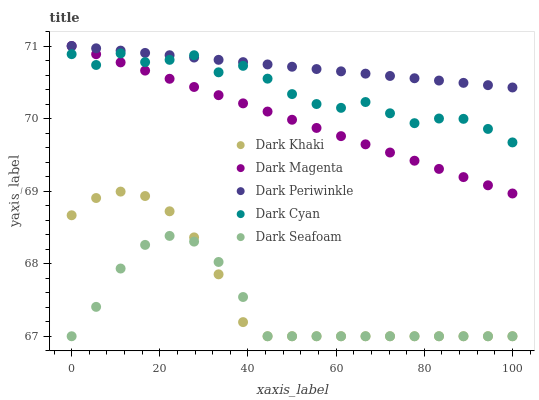Does Dark Seafoam have the minimum area under the curve?
Answer yes or no. Yes. Does Dark Periwinkle have the maximum area under the curve?
Answer yes or no. Yes. Does Dark Cyan have the minimum area under the curve?
Answer yes or no. No. Does Dark Cyan have the maximum area under the curve?
Answer yes or no. No. Is Dark Magenta the smoothest?
Answer yes or no. Yes. Is Dark Cyan the roughest?
Answer yes or no. Yes. Is Dark Seafoam the smoothest?
Answer yes or no. No. Is Dark Seafoam the roughest?
Answer yes or no. No. Does Dark Khaki have the lowest value?
Answer yes or no. Yes. Does Dark Cyan have the lowest value?
Answer yes or no. No. Does Dark Periwinkle have the highest value?
Answer yes or no. Yes. Does Dark Cyan have the highest value?
Answer yes or no. No. Is Dark Seafoam less than Dark Cyan?
Answer yes or no. Yes. Is Dark Magenta greater than Dark Seafoam?
Answer yes or no. Yes. Does Dark Cyan intersect Dark Magenta?
Answer yes or no. Yes. Is Dark Cyan less than Dark Magenta?
Answer yes or no. No. Is Dark Cyan greater than Dark Magenta?
Answer yes or no. No. Does Dark Seafoam intersect Dark Cyan?
Answer yes or no. No. 